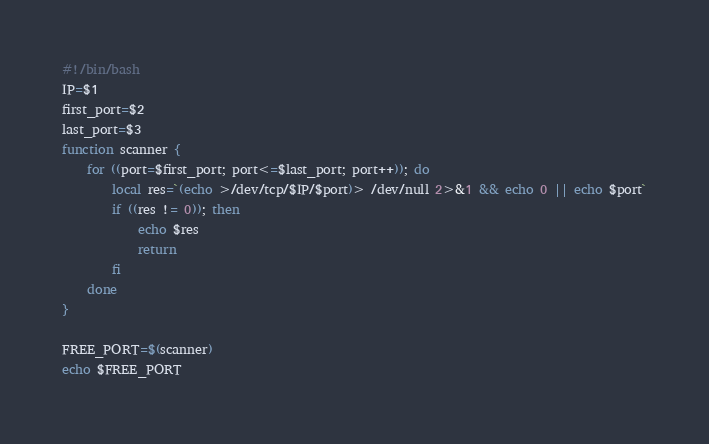Convert code to text. <code><loc_0><loc_0><loc_500><loc_500><_Bash_>#!/bin/bash
IP=$1
first_port=$2
last_port=$3
function scanner {
	for ((port=$first_port; port<=$last_port; port++)); do
		local res=`(echo >/dev/tcp/$IP/$port)> /dev/null 2>&1 && echo 0 || echo $port`
		if ((res != 0)); then
			echo $res
			return
		fi
    done
}

FREE_PORT=$(scanner)
echo $FREE_PORT
</code> 